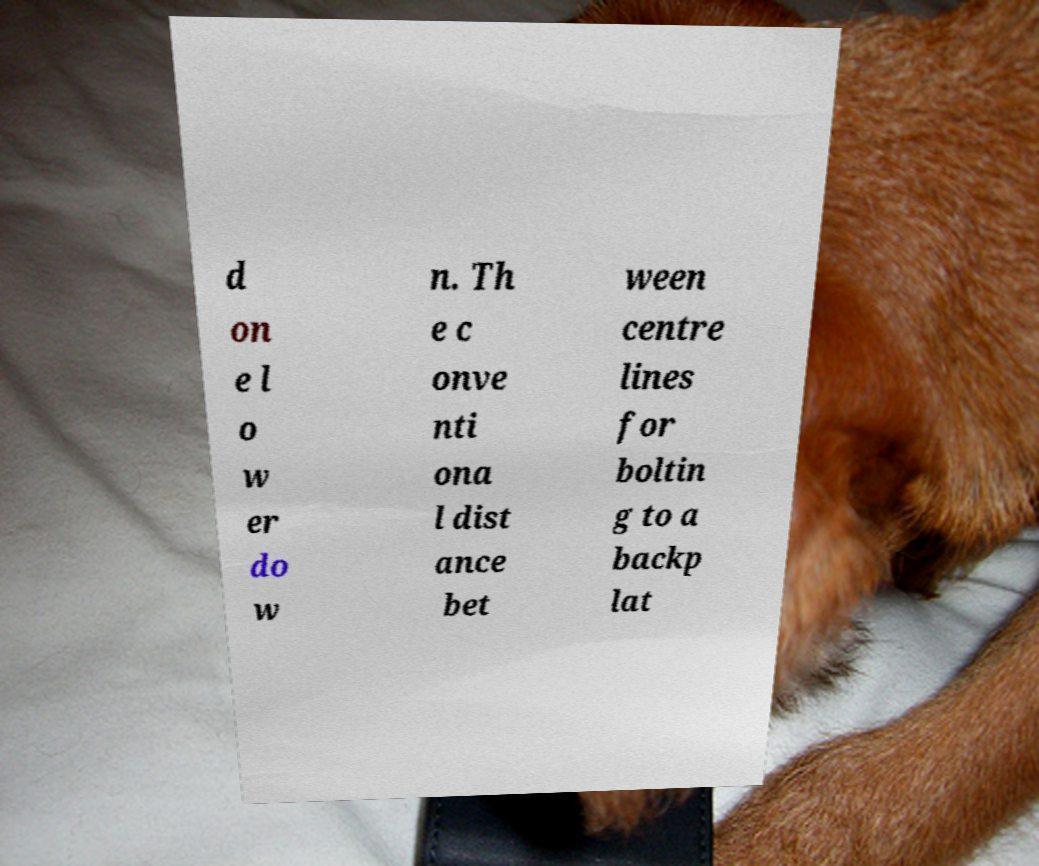For documentation purposes, I need the text within this image transcribed. Could you provide that? d on e l o w er do w n. Th e c onve nti ona l dist ance bet ween centre lines for boltin g to a backp lat 